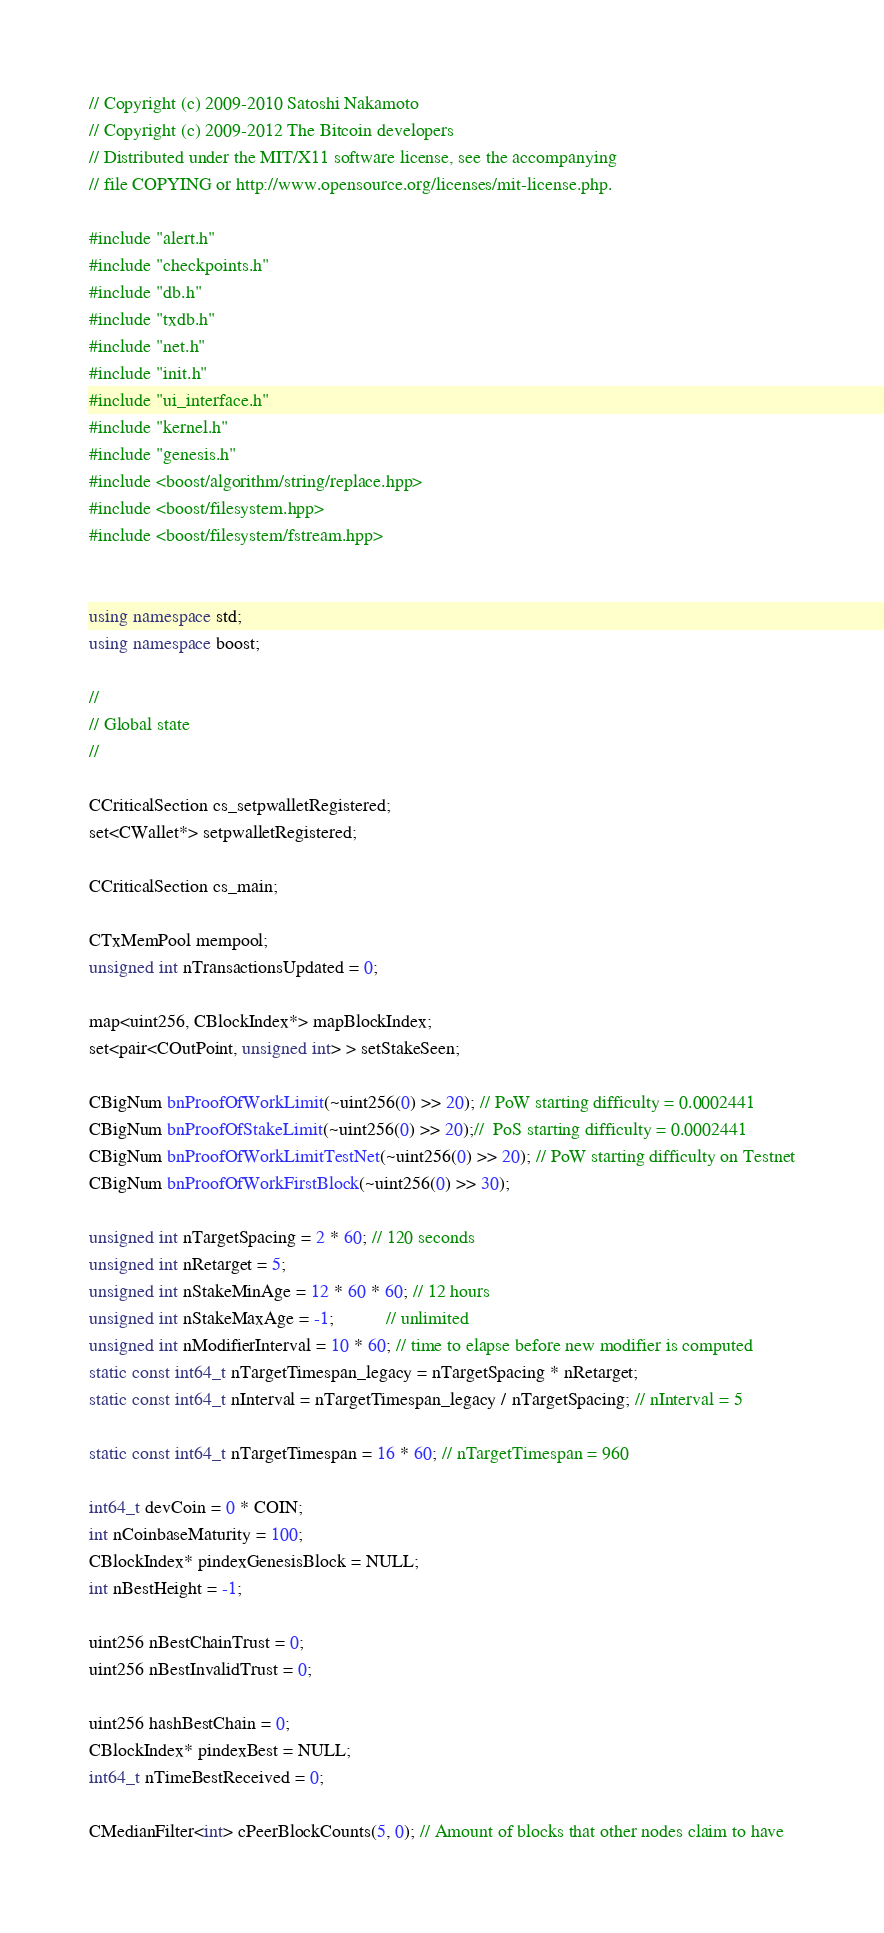<code> <loc_0><loc_0><loc_500><loc_500><_C++_>// Copyright (c) 2009-2010 Satoshi Nakamoto
// Copyright (c) 2009-2012 The Bitcoin developers
// Distributed under the MIT/X11 software license, see the accompanying
// file COPYING or http://www.opensource.org/licenses/mit-license.php.

#include "alert.h"
#include "checkpoints.h"
#include "db.h"
#include "txdb.h"
#include "net.h"
#include "init.h"
#include "ui_interface.h"
#include "kernel.h"
#include "genesis.h"
#include <boost/algorithm/string/replace.hpp>
#include <boost/filesystem.hpp>
#include <boost/filesystem/fstream.hpp>


using namespace std;
using namespace boost;

//
// Global state
//

CCriticalSection cs_setpwalletRegistered;
set<CWallet*> setpwalletRegistered;

CCriticalSection cs_main;

CTxMemPool mempool;
unsigned int nTransactionsUpdated = 0;

map<uint256, CBlockIndex*> mapBlockIndex;
set<pair<COutPoint, unsigned int> > setStakeSeen;

CBigNum bnProofOfWorkLimit(~uint256(0) >> 20); // PoW starting difficulty = 0.0002441
CBigNum bnProofOfStakeLimit(~uint256(0) >> 20);//  PoS starting difficulty = 0.0002441
CBigNum bnProofOfWorkLimitTestNet(~uint256(0) >> 20); // PoW starting difficulty on Testnet
CBigNum bnProofOfWorkFirstBlock(~uint256(0) >> 30);

unsigned int nTargetSpacing = 2 * 60; // 120 seconds
unsigned int nRetarget = 5;
unsigned int nStakeMinAge = 12 * 60 * 60; // 12 hours
unsigned int nStakeMaxAge = -1;           // unlimited
unsigned int nModifierInterval = 10 * 60; // time to elapse before new modifier is computed
static const int64_t nTargetTimespan_legacy = nTargetSpacing * nRetarget; 
static const int64_t nInterval = nTargetTimespan_legacy / nTargetSpacing; // nInterval = 5

static const int64_t nTargetTimespan = 16 * 60; // nTargetTimespan = 960

int64_t devCoin = 0 * COIN;
int nCoinbaseMaturity = 100;
CBlockIndex* pindexGenesisBlock = NULL;
int nBestHeight = -1;

uint256 nBestChainTrust = 0;
uint256 nBestInvalidTrust = 0;

uint256 hashBestChain = 0;
CBlockIndex* pindexBest = NULL;
int64_t nTimeBestReceived = 0;

CMedianFilter<int> cPeerBlockCounts(5, 0); // Amount of blocks that other nodes claim to have
</code> 